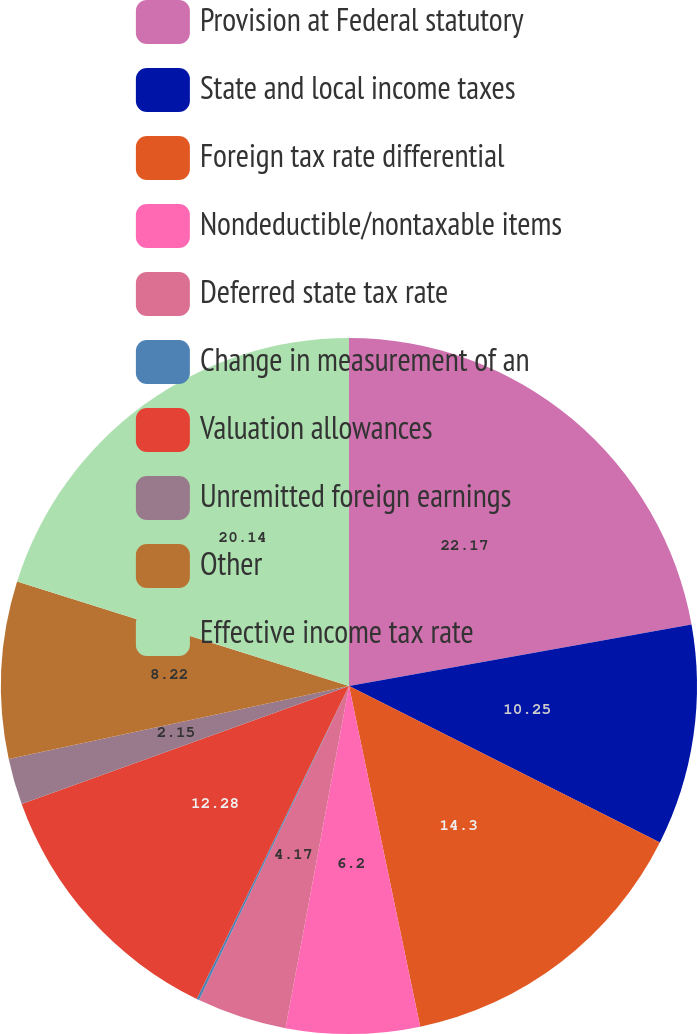<chart> <loc_0><loc_0><loc_500><loc_500><pie_chart><fcel>Provision at Federal statutory<fcel>State and local income taxes<fcel>Foreign tax rate differential<fcel>Nondeductible/nontaxable items<fcel>Deferred state tax rate<fcel>Change in measurement of an<fcel>Valuation allowances<fcel>Unremitted foreign earnings<fcel>Other<fcel>Effective income tax rate<nl><fcel>22.17%<fcel>10.25%<fcel>14.3%<fcel>6.2%<fcel>4.17%<fcel>0.12%<fcel>12.28%<fcel>2.15%<fcel>8.22%<fcel>20.14%<nl></chart> 